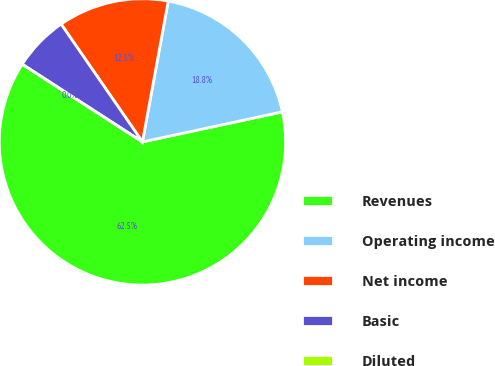Convert chart. <chart><loc_0><loc_0><loc_500><loc_500><pie_chart><fcel>Revenues<fcel>Operating income<fcel>Net income<fcel>Basic<fcel>Diluted<nl><fcel>62.5%<fcel>18.75%<fcel>12.5%<fcel>6.25%<fcel>0.0%<nl></chart> 